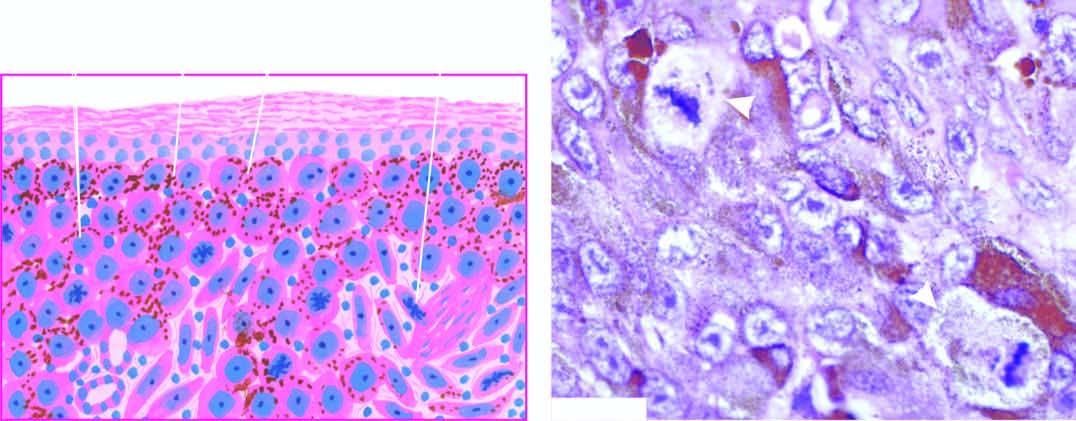does the granuloma show a prominent atypical mitotic figure?
Answer the question using a single word or phrase. No 